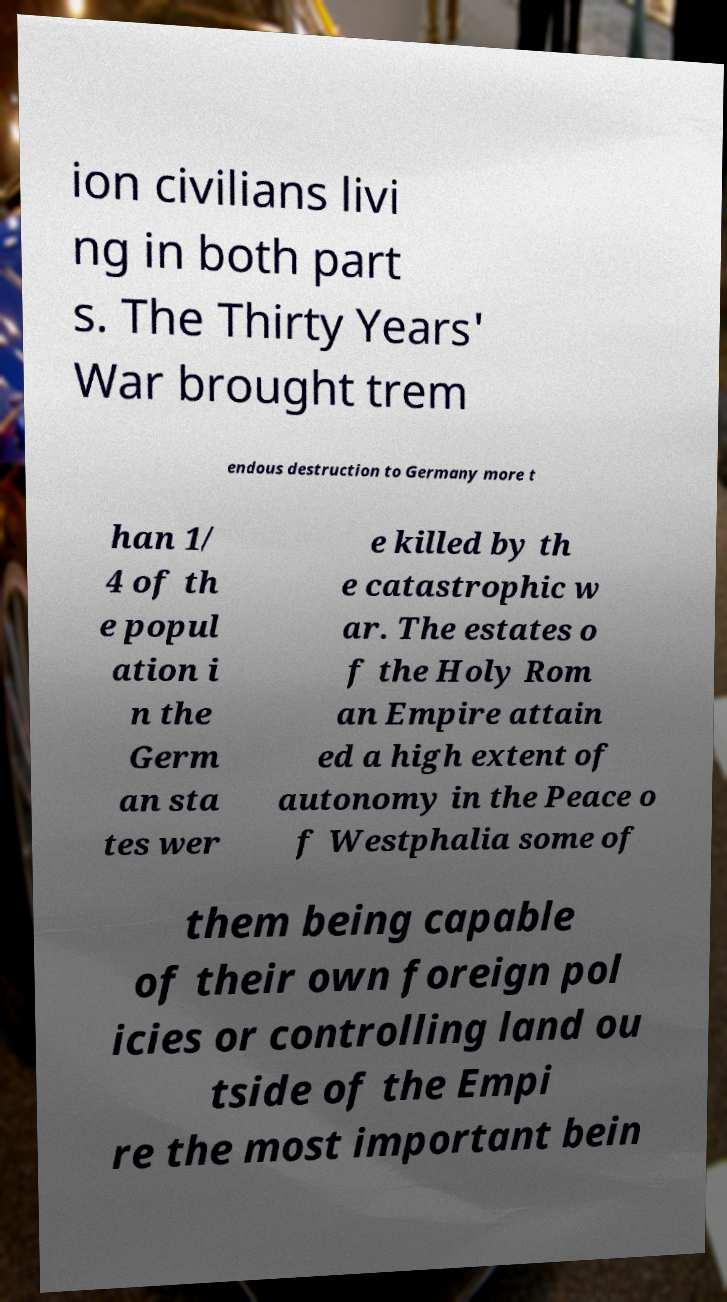Can you read and provide the text displayed in the image?This photo seems to have some interesting text. Can you extract and type it out for me? ion civilians livi ng in both part s. The Thirty Years' War brought trem endous destruction to Germany more t han 1/ 4 of th e popul ation i n the Germ an sta tes wer e killed by th e catastrophic w ar. The estates o f the Holy Rom an Empire attain ed a high extent of autonomy in the Peace o f Westphalia some of them being capable of their own foreign pol icies or controlling land ou tside of the Empi re the most important bein 